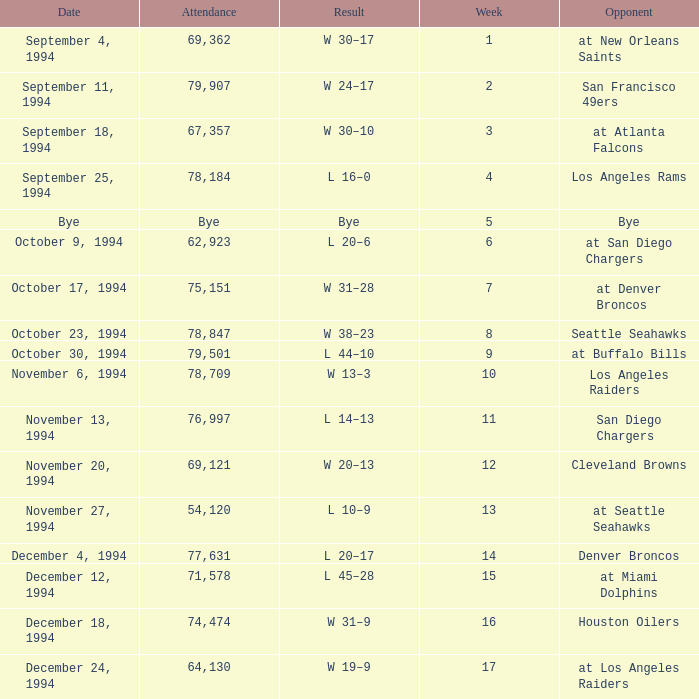What was the score of the Chiefs November 27, 1994 game? L 10–9. Can you give me this table as a dict? {'header': ['Date', 'Attendance', 'Result', 'Week', 'Opponent'], 'rows': [['September 4, 1994', '69,362', 'W 30–17', '1', 'at New Orleans Saints'], ['September 11, 1994', '79,907', 'W 24–17', '2', 'San Francisco 49ers'], ['September 18, 1994', '67,357', 'W 30–10', '3', 'at Atlanta Falcons'], ['September 25, 1994', '78,184', 'L 16–0', '4', 'Los Angeles Rams'], ['Bye', 'Bye', 'Bye', '5', 'Bye'], ['October 9, 1994', '62,923', 'L 20–6', '6', 'at San Diego Chargers'], ['October 17, 1994', '75,151', 'W 31–28', '7', 'at Denver Broncos'], ['October 23, 1994', '78,847', 'W 38–23', '8', 'Seattle Seahawks'], ['October 30, 1994', '79,501', 'L 44–10', '9', 'at Buffalo Bills'], ['November 6, 1994', '78,709', 'W 13–3', '10', 'Los Angeles Raiders'], ['November 13, 1994', '76,997', 'L 14–13', '11', 'San Diego Chargers'], ['November 20, 1994', '69,121', 'W 20–13', '12', 'Cleveland Browns'], ['November 27, 1994', '54,120', 'L 10–9', '13', 'at Seattle Seahawks'], ['December 4, 1994', '77,631', 'L 20–17', '14', 'Denver Broncos'], ['December 12, 1994', '71,578', 'L 45–28', '15', 'at Miami Dolphins'], ['December 18, 1994', '74,474', 'W 31–9', '16', 'Houston Oilers'], ['December 24, 1994', '64,130', 'W 19–9', '17', 'at Los Angeles Raiders']]} 